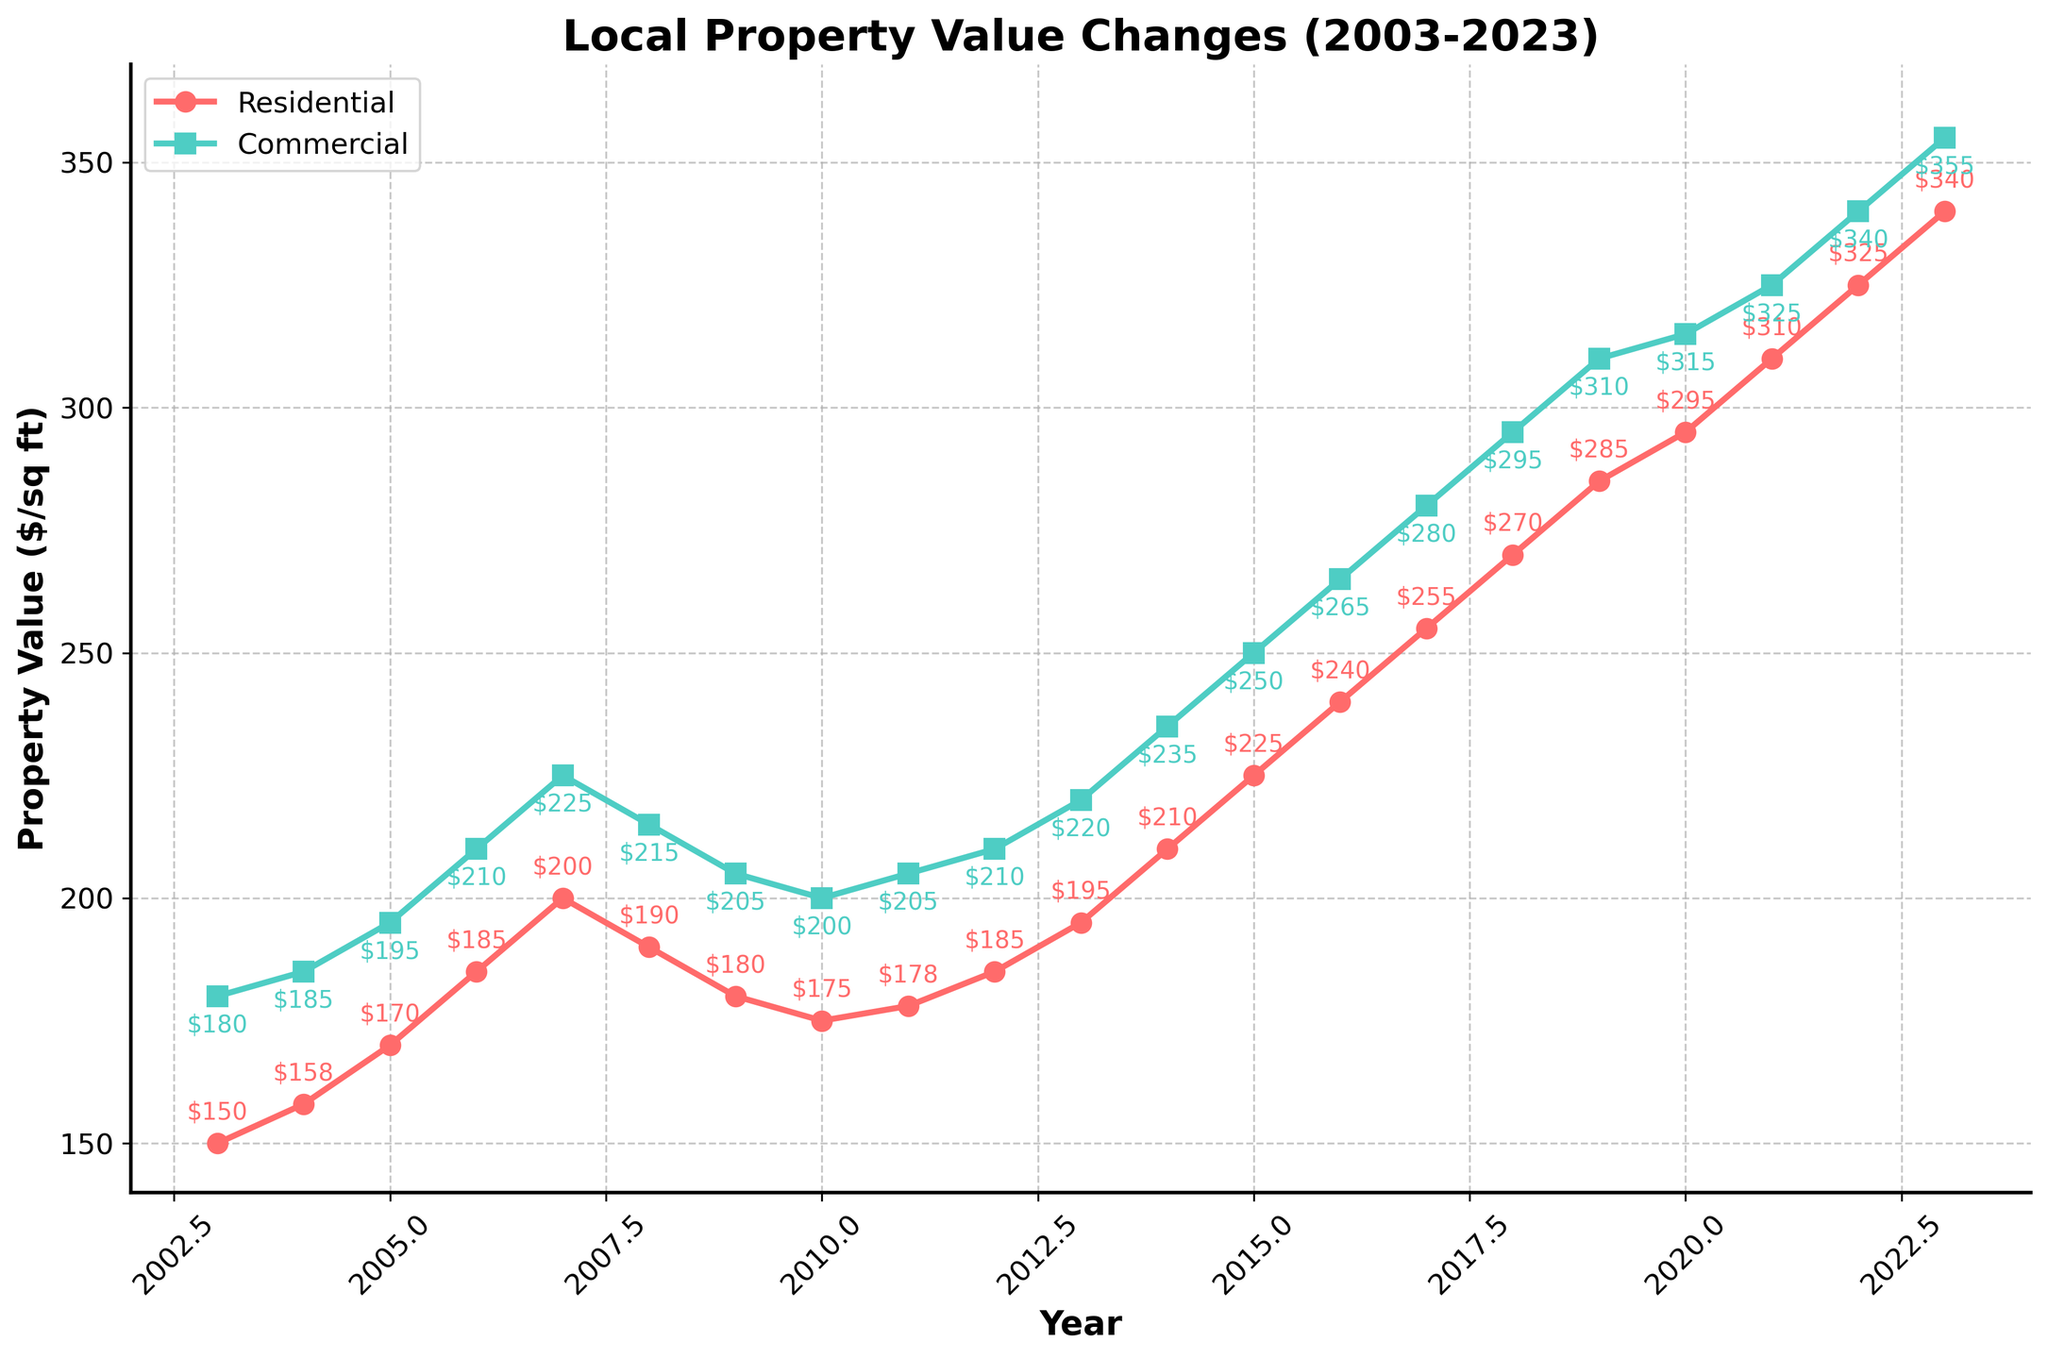What's the value difference between residential and commercial properties in 2023? Identify the value of residential properties in 2023 ($340) and commercial properties in 2023 ($355). Subtract the values: $355 - $340.
Answer: $15 During which year did residential properties first reach $200 per square foot? Look for the first year in the residential property line where the value reaches or exceeds $200. In 2007, residential property value is $200.
Answer: 2007 What was the average commercial property value from 2010 to 2013? Add commercial property values from 2010 to 2013: $200 + $205 + $210 + $220 = $835. Divide by the number of years (4).
Answer: $208.75 In which year did commercial property values decrease for the first time after 2007? Identify yearly commercial values and look for the first decrease after 2007. The value drops from 2008 ($215) to 2009 ($205).
Answer: 2009 What is the maximum value reached by residential properties in this time span? Scan the residential property line for the highest point, which is $340 in 2023.
Answer: $340 In what years did residential property values decline? Find years where the residential property value decreased compared to the previous year. They are 2008, 2009, and 2010.
Answer: 2008, 2009, 2010 Which year had the largest increase in residential property value compared to the previous year? Calculate the yearly differences and identify the largest one. From 2004 to 2005, the increase was $170 - $158 = $12. From 2005 to 2006, it was $185 - $170 = $15, and so forth. The largest increase is from 2022 ($325) to 2023 ($340), an increase of $15.
Answer: 2023 What overall trend can be observed in commercial property values from 2003 to 2023? Observe the general direction of the commercial property line, identifying that it generally increases over time despite a few minor decreases.
Answer: Increasing trend Between 2008 and 2010, which type of property saw a greater decrease in value? By how much? Calculate the decrease for both property types in this period. Residential: $190 to $175 = $15 decrease. Commercial: $215 to $200 = $15 decrease. Both types saw equal decreases.
Answer: Both saw a $15 decrease How did the residential and commercial values compare in 2005? Observe the values in 2005: Residential is $170 and Commercial is $195. Commercial is higher than residential.
Answer: Commercial values were higher than residential 